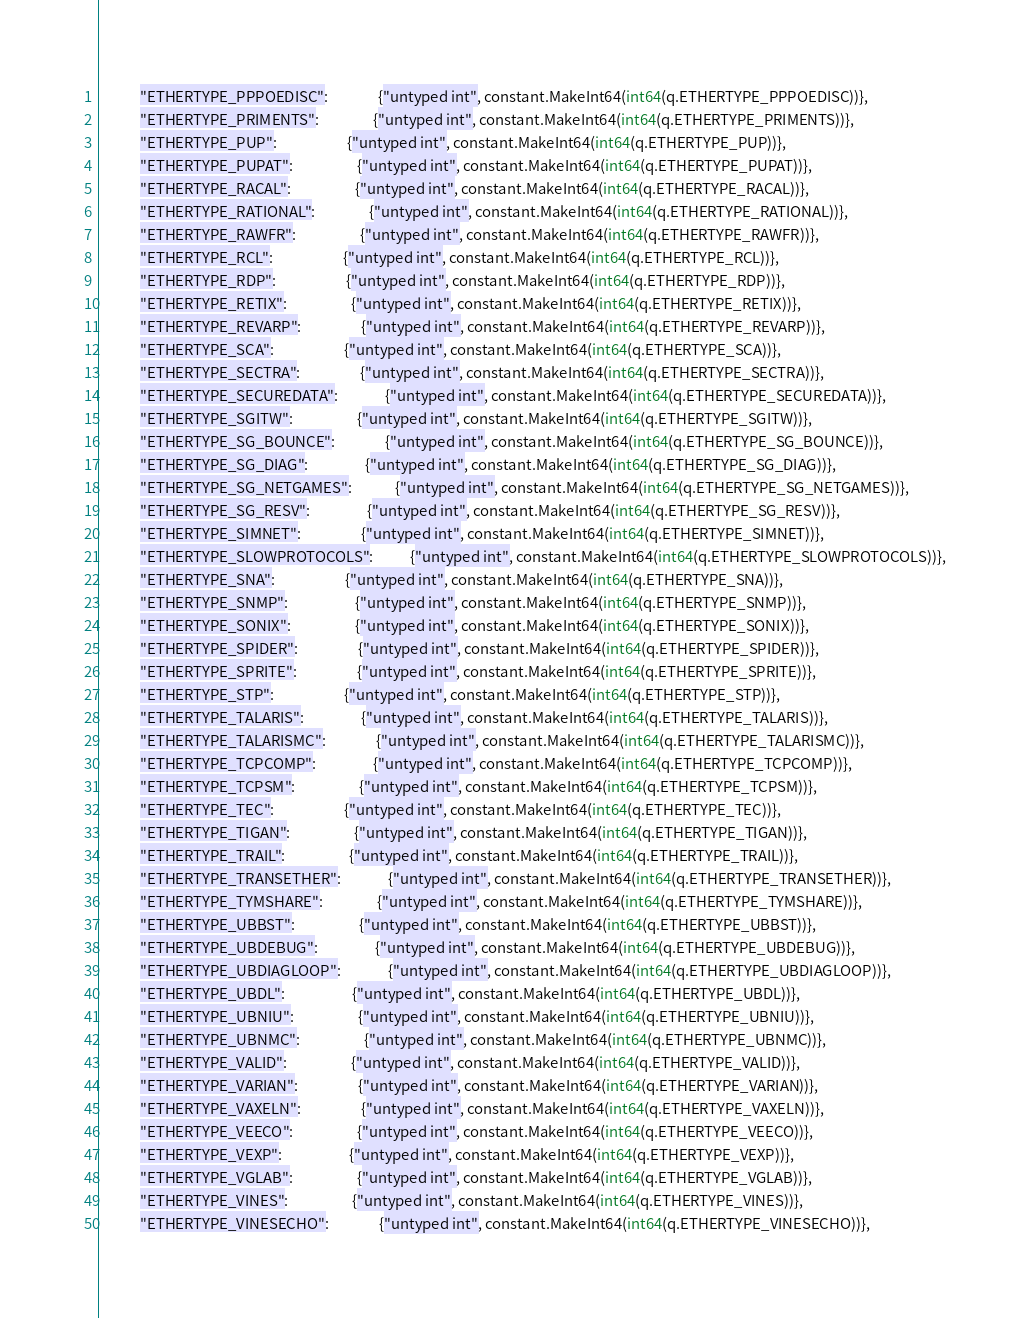Convert code to text. <code><loc_0><loc_0><loc_500><loc_500><_Go_>			"ETHERTYPE_PPPOEDISC":               {"untyped int", constant.MakeInt64(int64(q.ETHERTYPE_PPPOEDISC))},
			"ETHERTYPE_PRIMENTS":                {"untyped int", constant.MakeInt64(int64(q.ETHERTYPE_PRIMENTS))},
			"ETHERTYPE_PUP":                     {"untyped int", constant.MakeInt64(int64(q.ETHERTYPE_PUP))},
			"ETHERTYPE_PUPAT":                   {"untyped int", constant.MakeInt64(int64(q.ETHERTYPE_PUPAT))},
			"ETHERTYPE_RACAL":                   {"untyped int", constant.MakeInt64(int64(q.ETHERTYPE_RACAL))},
			"ETHERTYPE_RATIONAL":                {"untyped int", constant.MakeInt64(int64(q.ETHERTYPE_RATIONAL))},
			"ETHERTYPE_RAWFR":                   {"untyped int", constant.MakeInt64(int64(q.ETHERTYPE_RAWFR))},
			"ETHERTYPE_RCL":                     {"untyped int", constant.MakeInt64(int64(q.ETHERTYPE_RCL))},
			"ETHERTYPE_RDP":                     {"untyped int", constant.MakeInt64(int64(q.ETHERTYPE_RDP))},
			"ETHERTYPE_RETIX":                   {"untyped int", constant.MakeInt64(int64(q.ETHERTYPE_RETIX))},
			"ETHERTYPE_REVARP":                  {"untyped int", constant.MakeInt64(int64(q.ETHERTYPE_REVARP))},
			"ETHERTYPE_SCA":                     {"untyped int", constant.MakeInt64(int64(q.ETHERTYPE_SCA))},
			"ETHERTYPE_SECTRA":                  {"untyped int", constant.MakeInt64(int64(q.ETHERTYPE_SECTRA))},
			"ETHERTYPE_SECUREDATA":              {"untyped int", constant.MakeInt64(int64(q.ETHERTYPE_SECUREDATA))},
			"ETHERTYPE_SGITW":                   {"untyped int", constant.MakeInt64(int64(q.ETHERTYPE_SGITW))},
			"ETHERTYPE_SG_BOUNCE":               {"untyped int", constant.MakeInt64(int64(q.ETHERTYPE_SG_BOUNCE))},
			"ETHERTYPE_SG_DIAG":                 {"untyped int", constant.MakeInt64(int64(q.ETHERTYPE_SG_DIAG))},
			"ETHERTYPE_SG_NETGAMES":             {"untyped int", constant.MakeInt64(int64(q.ETHERTYPE_SG_NETGAMES))},
			"ETHERTYPE_SG_RESV":                 {"untyped int", constant.MakeInt64(int64(q.ETHERTYPE_SG_RESV))},
			"ETHERTYPE_SIMNET":                  {"untyped int", constant.MakeInt64(int64(q.ETHERTYPE_SIMNET))},
			"ETHERTYPE_SLOWPROTOCOLS":           {"untyped int", constant.MakeInt64(int64(q.ETHERTYPE_SLOWPROTOCOLS))},
			"ETHERTYPE_SNA":                     {"untyped int", constant.MakeInt64(int64(q.ETHERTYPE_SNA))},
			"ETHERTYPE_SNMP":                    {"untyped int", constant.MakeInt64(int64(q.ETHERTYPE_SNMP))},
			"ETHERTYPE_SONIX":                   {"untyped int", constant.MakeInt64(int64(q.ETHERTYPE_SONIX))},
			"ETHERTYPE_SPIDER":                  {"untyped int", constant.MakeInt64(int64(q.ETHERTYPE_SPIDER))},
			"ETHERTYPE_SPRITE":                  {"untyped int", constant.MakeInt64(int64(q.ETHERTYPE_SPRITE))},
			"ETHERTYPE_STP":                     {"untyped int", constant.MakeInt64(int64(q.ETHERTYPE_STP))},
			"ETHERTYPE_TALARIS":                 {"untyped int", constant.MakeInt64(int64(q.ETHERTYPE_TALARIS))},
			"ETHERTYPE_TALARISMC":               {"untyped int", constant.MakeInt64(int64(q.ETHERTYPE_TALARISMC))},
			"ETHERTYPE_TCPCOMP":                 {"untyped int", constant.MakeInt64(int64(q.ETHERTYPE_TCPCOMP))},
			"ETHERTYPE_TCPSM":                   {"untyped int", constant.MakeInt64(int64(q.ETHERTYPE_TCPSM))},
			"ETHERTYPE_TEC":                     {"untyped int", constant.MakeInt64(int64(q.ETHERTYPE_TEC))},
			"ETHERTYPE_TIGAN":                   {"untyped int", constant.MakeInt64(int64(q.ETHERTYPE_TIGAN))},
			"ETHERTYPE_TRAIL":                   {"untyped int", constant.MakeInt64(int64(q.ETHERTYPE_TRAIL))},
			"ETHERTYPE_TRANSETHER":              {"untyped int", constant.MakeInt64(int64(q.ETHERTYPE_TRANSETHER))},
			"ETHERTYPE_TYMSHARE":                {"untyped int", constant.MakeInt64(int64(q.ETHERTYPE_TYMSHARE))},
			"ETHERTYPE_UBBST":                   {"untyped int", constant.MakeInt64(int64(q.ETHERTYPE_UBBST))},
			"ETHERTYPE_UBDEBUG":                 {"untyped int", constant.MakeInt64(int64(q.ETHERTYPE_UBDEBUG))},
			"ETHERTYPE_UBDIAGLOOP":              {"untyped int", constant.MakeInt64(int64(q.ETHERTYPE_UBDIAGLOOP))},
			"ETHERTYPE_UBDL":                    {"untyped int", constant.MakeInt64(int64(q.ETHERTYPE_UBDL))},
			"ETHERTYPE_UBNIU":                   {"untyped int", constant.MakeInt64(int64(q.ETHERTYPE_UBNIU))},
			"ETHERTYPE_UBNMC":                   {"untyped int", constant.MakeInt64(int64(q.ETHERTYPE_UBNMC))},
			"ETHERTYPE_VALID":                   {"untyped int", constant.MakeInt64(int64(q.ETHERTYPE_VALID))},
			"ETHERTYPE_VARIAN":                  {"untyped int", constant.MakeInt64(int64(q.ETHERTYPE_VARIAN))},
			"ETHERTYPE_VAXELN":                  {"untyped int", constant.MakeInt64(int64(q.ETHERTYPE_VAXELN))},
			"ETHERTYPE_VEECO":                   {"untyped int", constant.MakeInt64(int64(q.ETHERTYPE_VEECO))},
			"ETHERTYPE_VEXP":                    {"untyped int", constant.MakeInt64(int64(q.ETHERTYPE_VEXP))},
			"ETHERTYPE_VGLAB":                   {"untyped int", constant.MakeInt64(int64(q.ETHERTYPE_VGLAB))},
			"ETHERTYPE_VINES":                   {"untyped int", constant.MakeInt64(int64(q.ETHERTYPE_VINES))},
			"ETHERTYPE_VINESECHO":               {"untyped int", constant.MakeInt64(int64(q.ETHERTYPE_VINESECHO))},</code> 